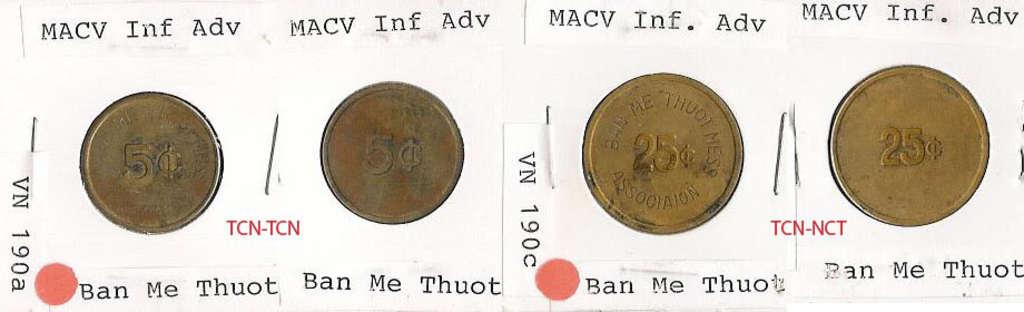What is featured on the poster in the image? There is a poster with information in the image. What else can be seen in the image besides the poster? There are coins visible in the image. How many girls are shown on the poster in the image? There are no girls depicted on the poster in the image; it only contains information. What type of lip product is visible in the image? There is no lip product present in the image. 